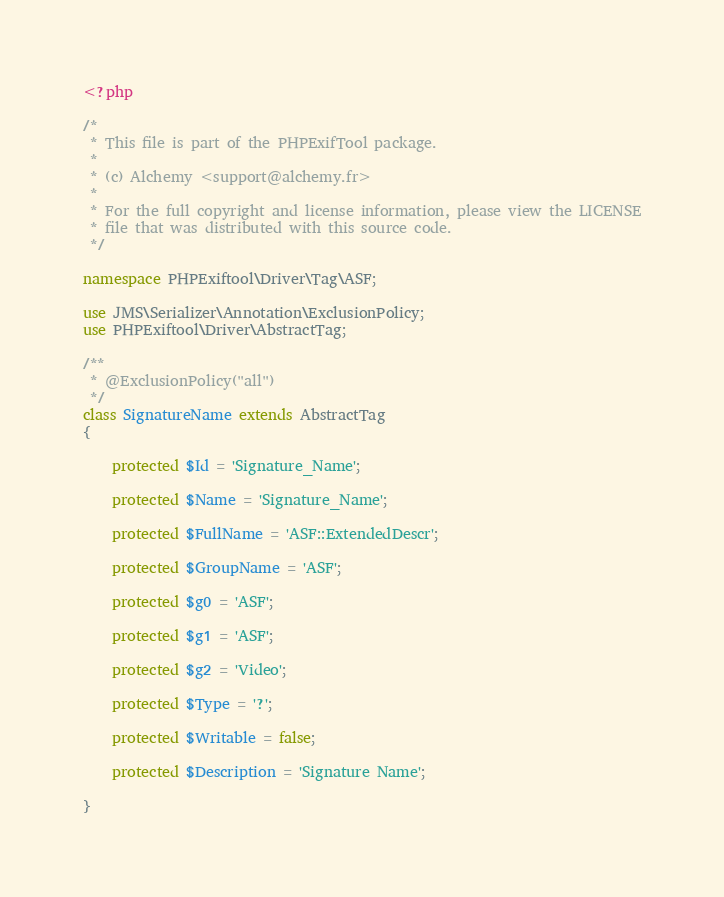<code> <loc_0><loc_0><loc_500><loc_500><_PHP_><?php

/*
 * This file is part of the PHPExifTool package.
 *
 * (c) Alchemy <support@alchemy.fr>
 *
 * For the full copyright and license information, please view the LICENSE
 * file that was distributed with this source code.
 */

namespace PHPExiftool\Driver\Tag\ASF;

use JMS\Serializer\Annotation\ExclusionPolicy;
use PHPExiftool\Driver\AbstractTag;

/**
 * @ExclusionPolicy("all")
 */
class SignatureName extends AbstractTag
{

    protected $Id = 'Signature_Name';

    protected $Name = 'Signature_Name';

    protected $FullName = 'ASF::ExtendedDescr';

    protected $GroupName = 'ASF';

    protected $g0 = 'ASF';

    protected $g1 = 'ASF';

    protected $g2 = 'Video';

    protected $Type = '?';

    protected $Writable = false;

    protected $Description = 'Signature Name';

}
</code> 